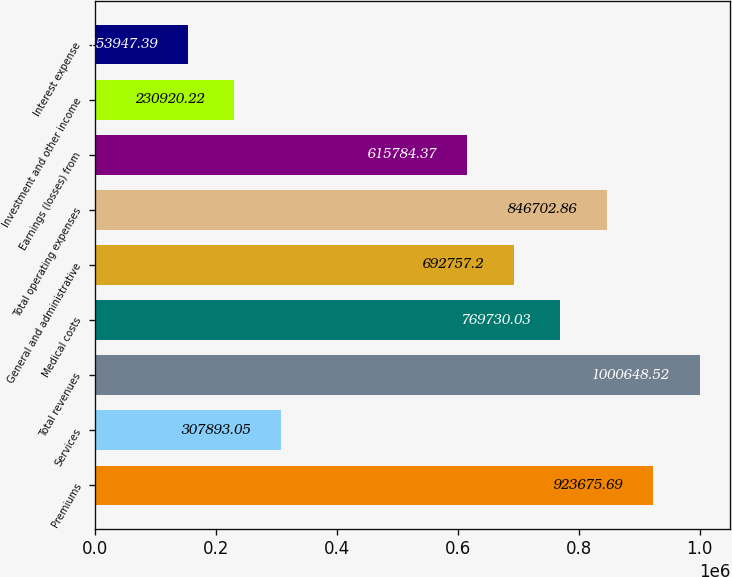Convert chart. <chart><loc_0><loc_0><loc_500><loc_500><bar_chart><fcel>Premiums<fcel>Services<fcel>Total revenues<fcel>Medical costs<fcel>General and administrative<fcel>Total operating expenses<fcel>Earnings (losses) from<fcel>Investment and other income<fcel>Interest expense<nl><fcel>923676<fcel>307893<fcel>1.00065e+06<fcel>769730<fcel>692757<fcel>846703<fcel>615784<fcel>230920<fcel>153947<nl></chart> 